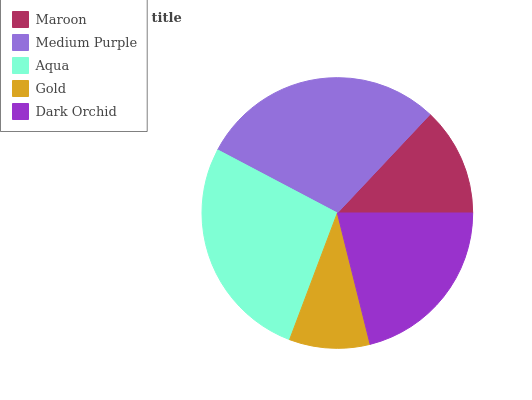Is Gold the minimum?
Answer yes or no. Yes. Is Medium Purple the maximum?
Answer yes or no. Yes. Is Aqua the minimum?
Answer yes or no. No. Is Aqua the maximum?
Answer yes or no. No. Is Medium Purple greater than Aqua?
Answer yes or no. Yes. Is Aqua less than Medium Purple?
Answer yes or no. Yes. Is Aqua greater than Medium Purple?
Answer yes or no. No. Is Medium Purple less than Aqua?
Answer yes or no. No. Is Dark Orchid the high median?
Answer yes or no. Yes. Is Dark Orchid the low median?
Answer yes or no. Yes. Is Medium Purple the high median?
Answer yes or no. No. Is Aqua the low median?
Answer yes or no. No. 